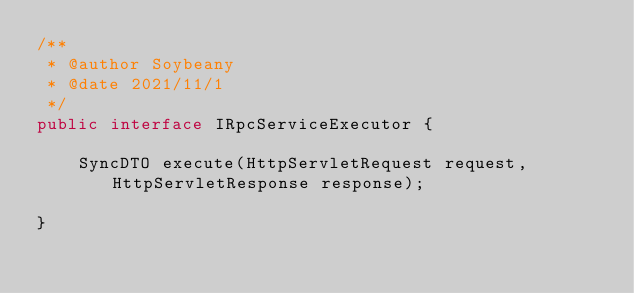<code> <loc_0><loc_0><loc_500><loc_500><_Java_>/**
 * @author Soybeany
 * @date 2021/11/1
 */
public interface IRpcServiceExecutor {

    SyncDTO execute(HttpServletRequest request, HttpServletResponse response);

}
</code> 